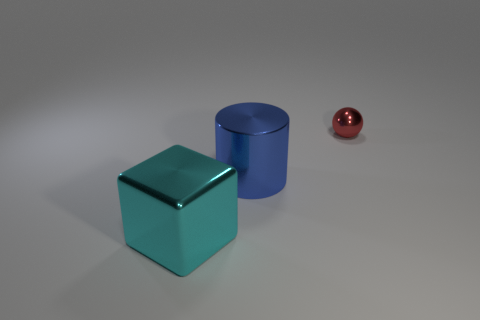How many objects are objects that are on the right side of the big blue cylinder or large red things?
Your answer should be compact. 1. Are there any tiny green matte things of the same shape as the small metallic object?
Keep it short and to the point. No. Are there the same number of large cyan cubes to the left of the large block and big cyan objects?
Keep it short and to the point. No. What number of blue things have the same size as the blue metallic cylinder?
Provide a short and direct response. 0. There is a big cylinder; what number of large cyan objects are in front of it?
Your answer should be compact. 1. There is a big thing behind the thing that is in front of the blue cylinder; what is it made of?
Give a very brief answer. Metal. Are there any other rubber cylinders that have the same color as the cylinder?
Make the answer very short. No. There is a cube that is made of the same material as the red ball; what is its size?
Your answer should be very brief. Large. Is there any other thing that has the same color as the tiny shiny object?
Provide a succinct answer. No. What color is the big thing that is in front of the metallic cylinder?
Your answer should be compact. Cyan. 